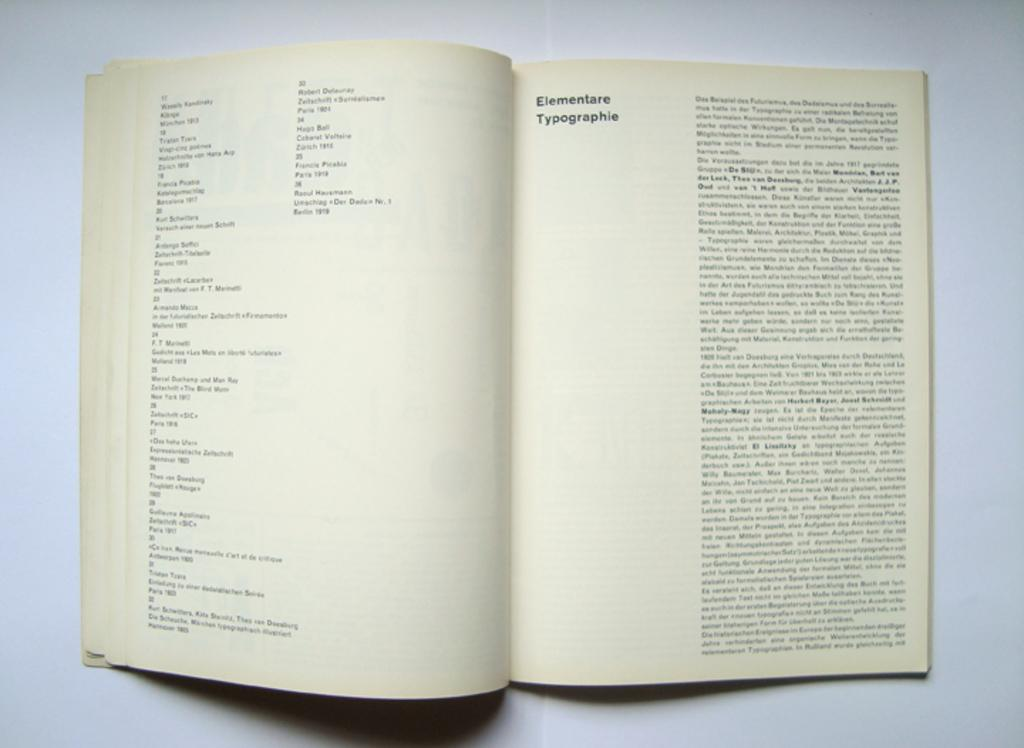<image>
Create a compact narrative representing the image presented. A book is opened to the chapter entitled Elementare Typographie. 